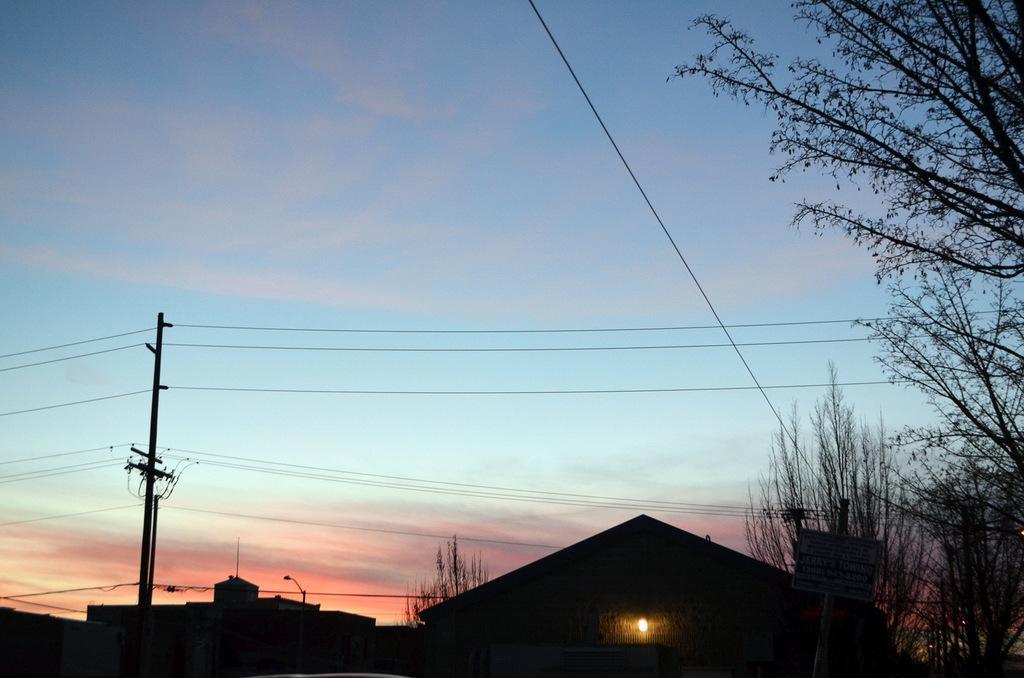Describe this image in one or two sentences. In this image there are houses, electrical pole and trees, in the background there is a blue sky. 